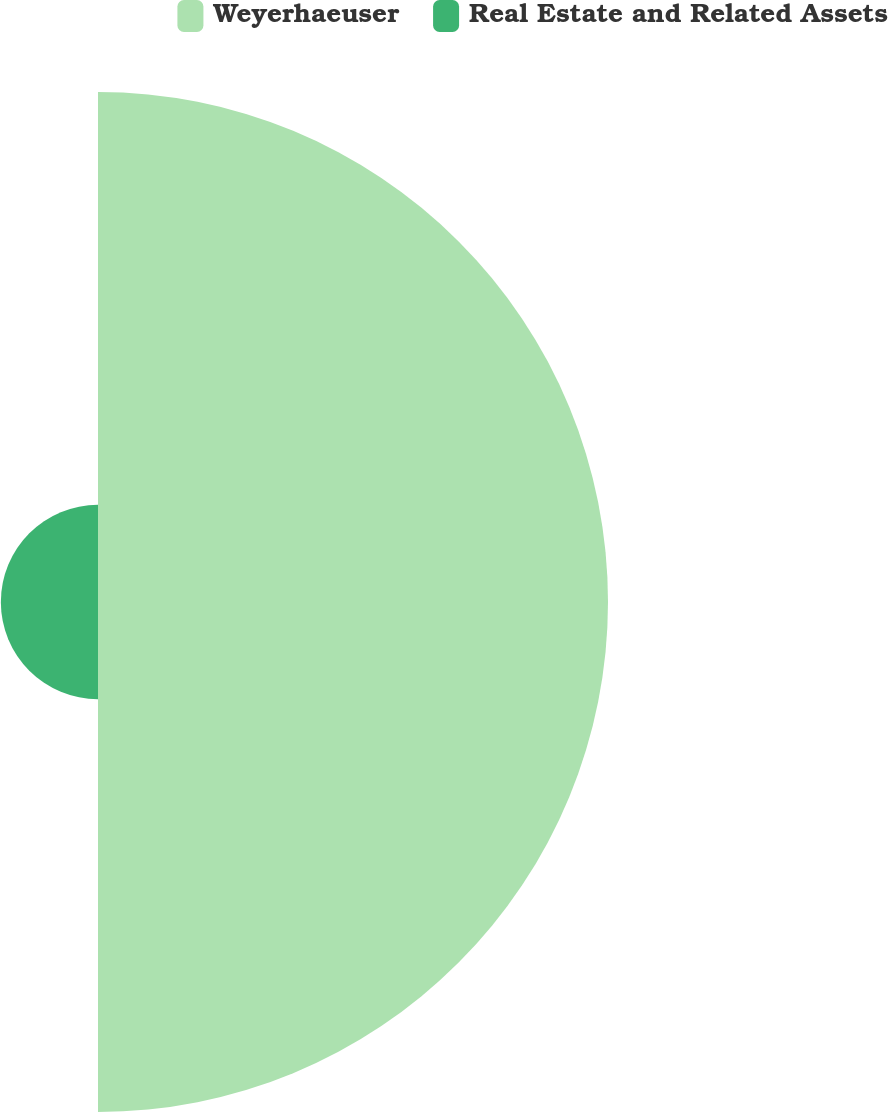Convert chart. <chart><loc_0><loc_0><loc_500><loc_500><pie_chart><fcel>Weyerhaeuser<fcel>Real Estate and Related Assets<nl><fcel>84.0%<fcel>16.0%<nl></chart> 